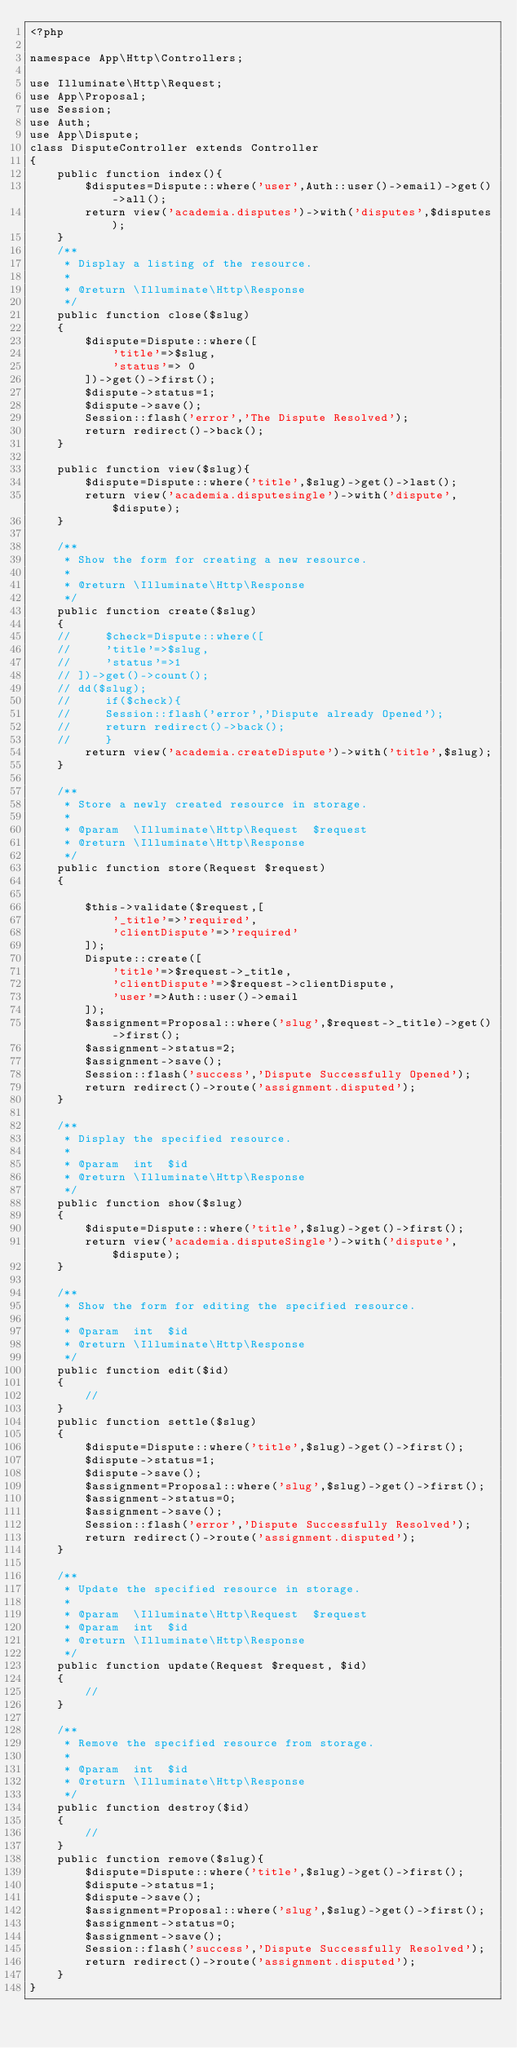Convert code to text. <code><loc_0><loc_0><loc_500><loc_500><_PHP_><?php

namespace App\Http\Controllers;

use Illuminate\Http\Request;
use App\Proposal;
use Session;
use Auth;
use App\Dispute;
class DisputeController extends Controller
{
    public function index(){
        $disputes=Dispute::where('user',Auth::user()->email)->get()->all();
        return view('academia.disputes')->with('disputes',$disputes);
    }
    /**
     * Display a listing of the resource.
     *
     * @return \Illuminate\Http\Response
     */
    public function close($slug)
    {   
        $dispute=Dispute::where([
            'title'=>$slug,
            'status'=> 0
        ])->get()->first();
        $dispute->status=1;
        $dispute->save();
        Session::flash('error','The Dispute Resolved');
        return redirect()->back();
    }

    public function view($slug){
        $dispute=Dispute::where('title',$slug)->get()->last();
        return view('academia.disputesingle')->with('dispute',$dispute);
    }

    /**
     * Show the form for creating a new resource.
     *
     * @return \Illuminate\Http\Response
     */
    public function create($slug)
    {
    //     $check=Dispute::where([
    //     'title'=>$slug,
    //     'status'=>1
    // ])->get()->count();
    // dd($slug);
    //     if($check){
    //     Session::flash('error','Dispute already Opened');
    //     return redirect()->back();
    //     }
        return view('academia.createDispute')->with('title',$slug);
    }

    /**
     * Store a newly created resource in storage.
     *
     * @param  \Illuminate\Http\Request  $request
     * @return \Illuminate\Http\Response
     */
    public function store(Request $request)
    {   

        $this->validate($request,[
            '_title'=>'required',
            'clientDispute'=>'required'
        ]);
        Dispute::create([
            'title'=>$request->_title,
            'clientDispute'=>$request->clientDispute,
            'user'=>Auth::user()->email
        ]);
        $assignment=Proposal::where('slug',$request->_title)->get()->first();
        $assignment->status=2;
        $assignment->save();
        Session::flash('success','Dispute Successfully Opened');
        return redirect()->route('assignment.disputed');
    }

    /**
     * Display the specified resource.
     *
     * @param  int  $id
     * @return \Illuminate\Http\Response
     */
    public function show($slug)
    {   
        $dispute=Dispute::where('title',$slug)->get()->first();
        return view('academia.disputeSingle')->with('dispute',$dispute);
    }

    /**
     * Show the form for editing the specified resource.
     *
     * @param  int  $id
     * @return \Illuminate\Http\Response
     */
    public function edit($id)
    {
        //
    }
    public function settle($slug)
    {
        $dispute=Dispute::where('title',$slug)->get()->first();
        $dispute->status=1;
        $dispute->save();
        $assignment=Proposal::where('slug',$slug)->get()->first();
        $assignment->status=0;
        $assignment->save();
        Session::flash('error','Dispute Successfully Resolved');
        return redirect()->route('assignment.disputed');
    }

    /**
     * Update the specified resource in storage.
     *
     * @param  \Illuminate\Http\Request  $request
     * @param  int  $id
     * @return \Illuminate\Http\Response
     */
    public function update(Request $request, $id)
    {
        //
    }

    /**
     * Remove the specified resource from storage.
     *
     * @param  int  $id
     * @return \Illuminate\Http\Response
     */
    public function destroy($id)
    {
        //
    }
    public function remove($slug){
        $dispute=Dispute::where('title',$slug)->get()->first();
        $dispute->status=1;
        $dispute->save();
        $assignment=Proposal::where('slug',$slug)->get()->first();
        $assignment->status=0;
        $assignment->save();
        Session::flash('success','Dispute Successfully Resolved');
        return redirect()->route('assignment.disputed');
    }
}
</code> 